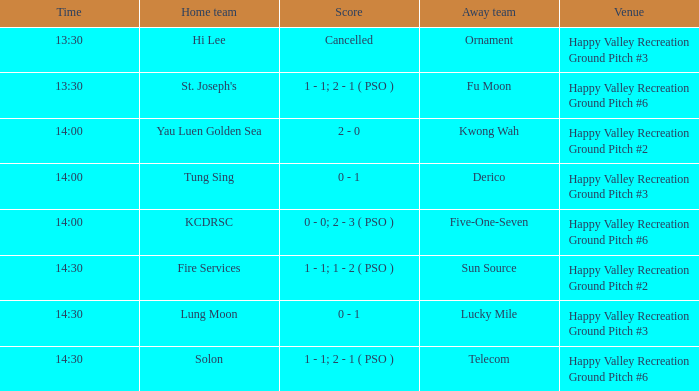What is the site of the contest at 14:30 and sun source representing the away side? Happy Valley Recreation Ground Pitch #2. Could you parse the entire table as a dict? {'header': ['Time', 'Home team', 'Score', 'Away team', 'Venue'], 'rows': [['13:30', 'Hi Lee', 'Cancelled', 'Ornament', 'Happy Valley Recreation Ground Pitch #3'], ['13:30', "St. Joseph's", '1 - 1; 2 - 1 ( PSO )', 'Fu Moon', 'Happy Valley Recreation Ground Pitch #6'], ['14:00', 'Yau Luen Golden Sea', '2 - 0', 'Kwong Wah', 'Happy Valley Recreation Ground Pitch #2'], ['14:00', 'Tung Sing', '0 - 1', 'Derico', 'Happy Valley Recreation Ground Pitch #3'], ['14:00', 'KCDRSC', '0 - 0; 2 - 3 ( PSO )', 'Five-One-Seven', 'Happy Valley Recreation Ground Pitch #6'], ['14:30', 'Fire Services', '1 - 1; 1 - 2 ( PSO )', 'Sun Source', 'Happy Valley Recreation Ground Pitch #2'], ['14:30', 'Lung Moon', '0 - 1', 'Lucky Mile', 'Happy Valley Recreation Ground Pitch #3'], ['14:30', 'Solon', '1 - 1; 2 - 1 ( PSO )', 'Telecom', 'Happy Valley Recreation Ground Pitch #6']]} 